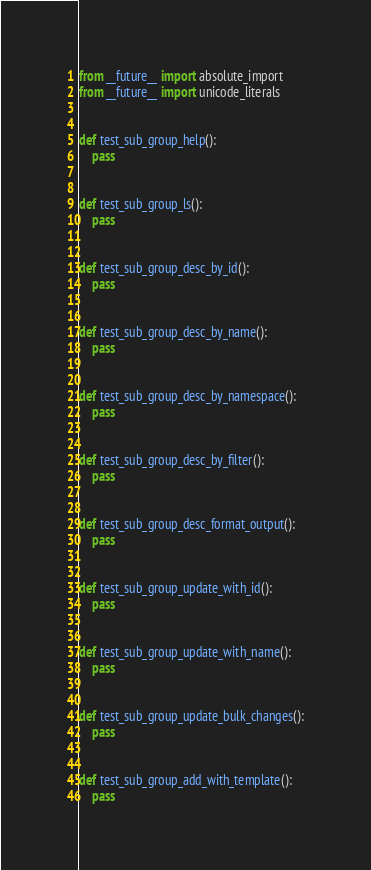<code> <loc_0><loc_0><loc_500><loc_500><_Python_>from __future__ import absolute_import
from __future__ import unicode_literals


def test_sub_group_help():
    pass


def test_sub_group_ls():
    pass


def test_sub_group_desc_by_id():
    pass


def test_sub_group_desc_by_name():
    pass


def test_sub_group_desc_by_namespace():
    pass


def test_sub_group_desc_by_filter():
    pass


def test_sub_group_desc_format_output():
    pass


def test_sub_group_update_with_id():
    pass


def test_sub_group_update_with_name():
    pass


def test_sub_group_update_bulk_changes():
    pass


def test_sub_group_add_with_template():
    pass
</code> 